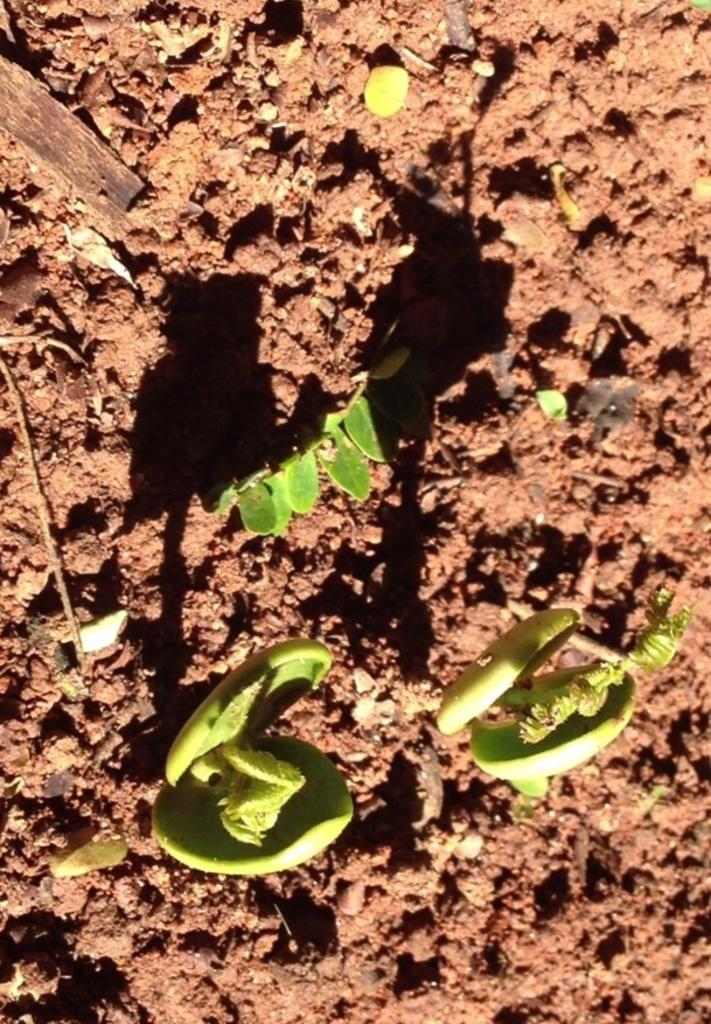What type of living organisms can be seen in the image? Plants can be seen in the image. What is the color of the plants in the image? The plants are green in color. What is the color of the background in the image? The background of the image is brown in color. What historical event is depicted in the image? There is no historical event depicted in the image; it features plants and a brown background. Can you tell me how the plants are running in the image? Plants do not run; they are stationary organisms. 